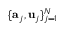<formula> <loc_0><loc_0><loc_500><loc_500>\{ a _ { j } , u _ { j } \} _ { j = 1 } ^ { N }</formula> 